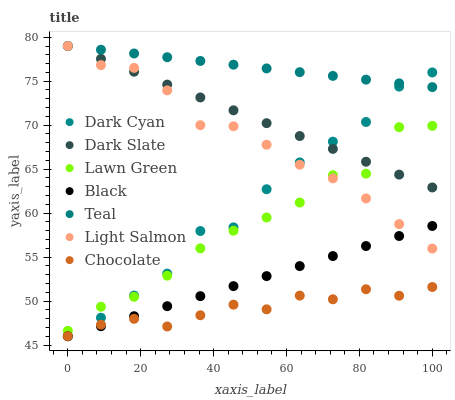Does Chocolate have the minimum area under the curve?
Answer yes or no. Yes. Does Teal have the maximum area under the curve?
Answer yes or no. Yes. Does Light Salmon have the minimum area under the curve?
Answer yes or no. No. Does Light Salmon have the maximum area under the curve?
Answer yes or no. No. Is Black the smoothest?
Answer yes or no. Yes. Is Lawn Green the roughest?
Answer yes or no. Yes. Is Light Salmon the smoothest?
Answer yes or no. No. Is Light Salmon the roughest?
Answer yes or no. No. Does Chocolate have the lowest value?
Answer yes or no. Yes. Does Light Salmon have the lowest value?
Answer yes or no. No. Does Teal have the highest value?
Answer yes or no. Yes. Does Chocolate have the highest value?
Answer yes or no. No. Is Black less than Dark Slate?
Answer yes or no. Yes. Is Teal greater than Chocolate?
Answer yes or no. Yes. Does Teal intersect Light Salmon?
Answer yes or no. Yes. Is Teal less than Light Salmon?
Answer yes or no. No. Is Teal greater than Light Salmon?
Answer yes or no. No. Does Black intersect Dark Slate?
Answer yes or no. No. 